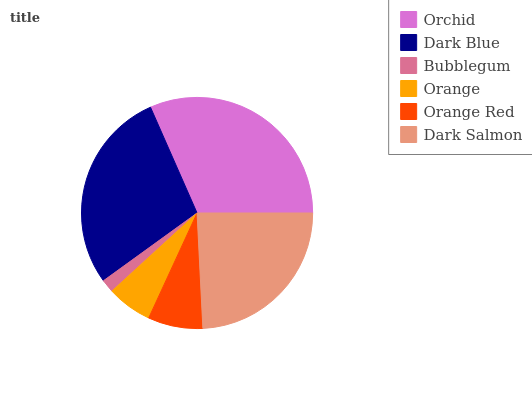Is Bubblegum the minimum?
Answer yes or no. Yes. Is Orchid the maximum?
Answer yes or no. Yes. Is Dark Blue the minimum?
Answer yes or no. No. Is Dark Blue the maximum?
Answer yes or no. No. Is Orchid greater than Dark Blue?
Answer yes or no. Yes. Is Dark Blue less than Orchid?
Answer yes or no. Yes. Is Dark Blue greater than Orchid?
Answer yes or no. No. Is Orchid less than Dark Blue?
Answer yes or no. No. Is Dark Salmon the high median?
Answer yes or no. Yes. Is Orange Red the low median?
Answer yes or no. Yes. Is Bubblegum the high median?
Answer yes or no. No. Is Dark Blue the low median?
Answer yes or no. No. 